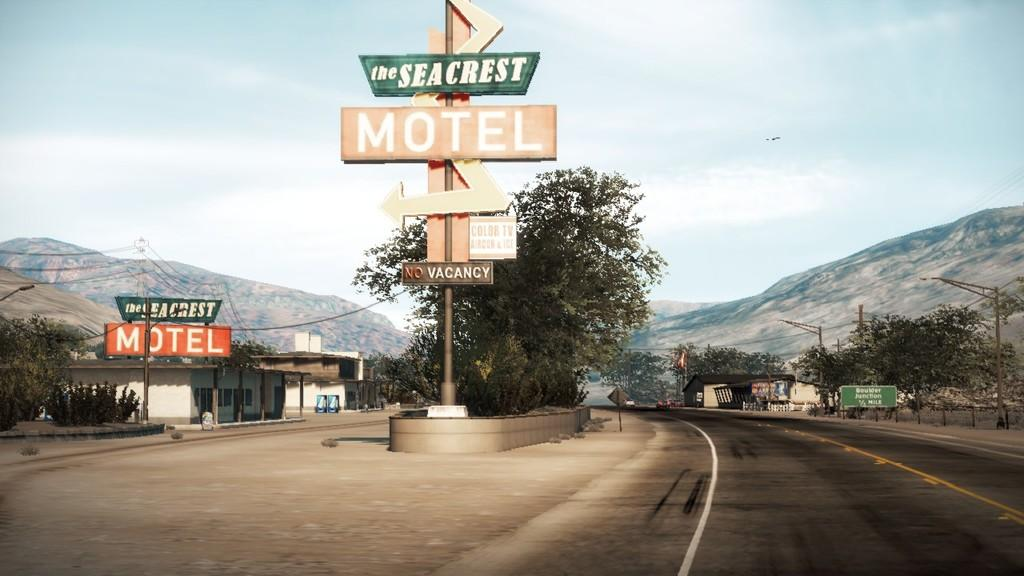<image>
Render a clear and concise summary of the photo. A sign for the seacrest motel and the vacancy sign. 